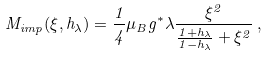Convert formula to latex. <formula><loc_0><loc_0><loc_500><loc_500>M _ { i m p } ( \xi , h _ { \lambda } ) = \frac { 1 } { 4 } \mu _ { B } g ^ { * } \lambda \frac { \xi ^ { 2 } } { \frac { 1 + h _ { \lambda } } { 1 - h _ { \lambda } } + \xi ^ { 2 } } \, ,</formula> 